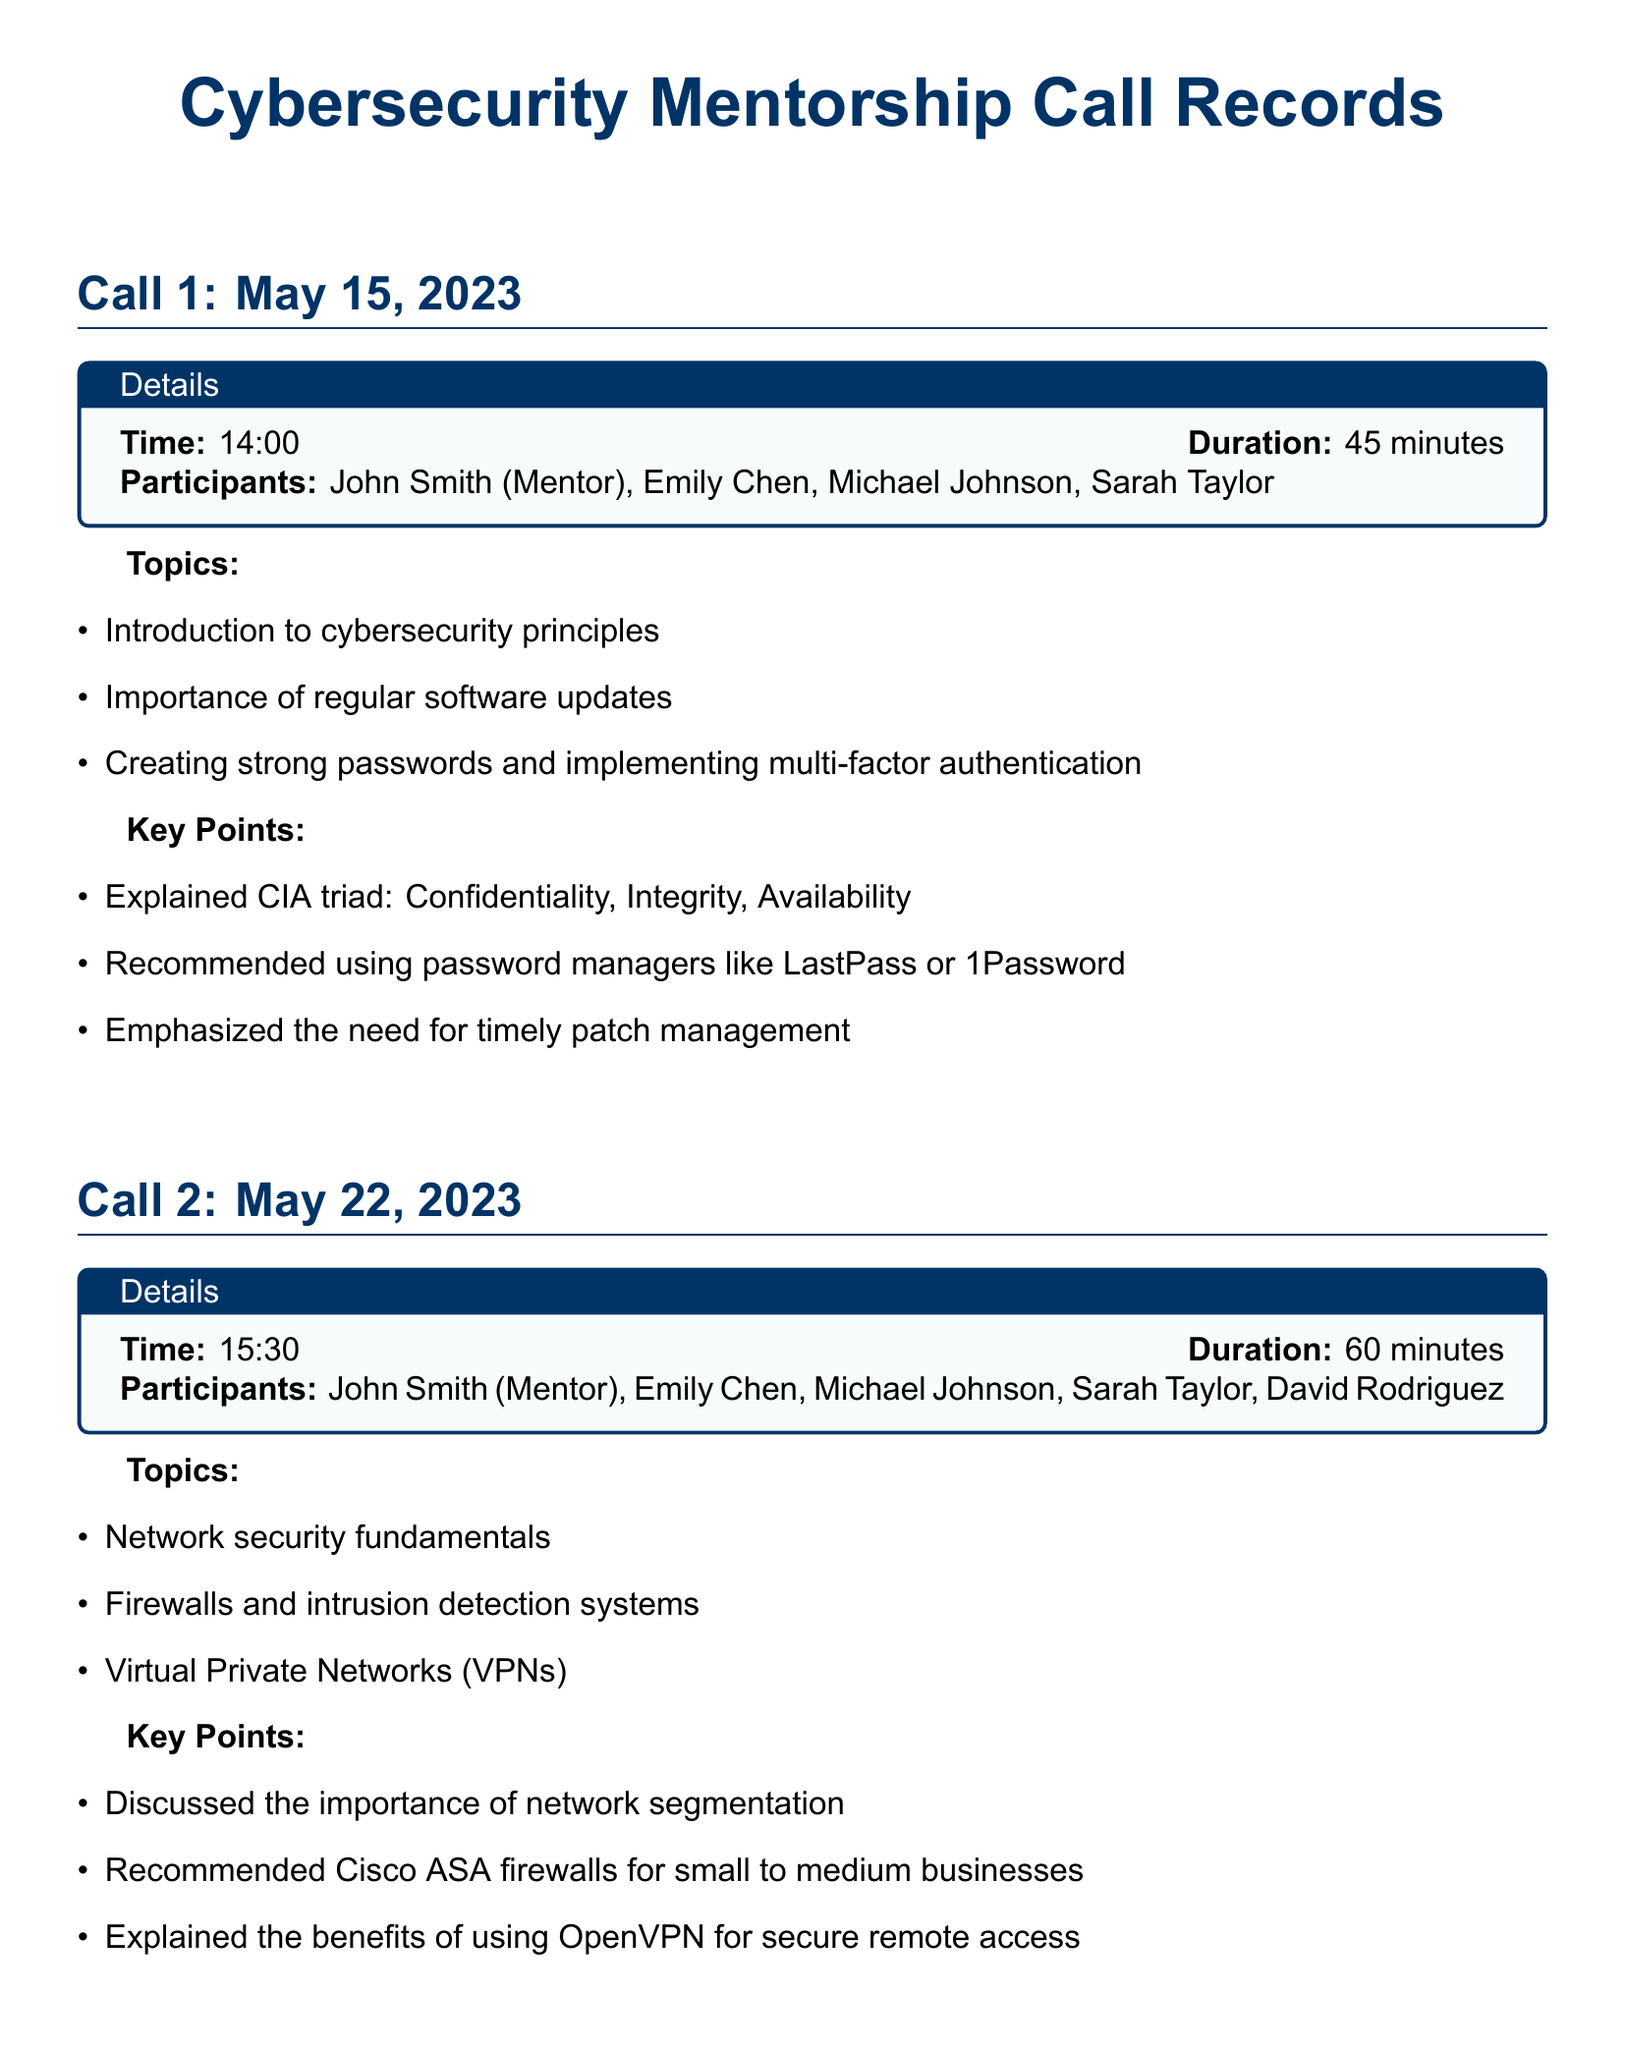What is the date of Call 1? The date of Call 1 is explicitly stated in the document under the section title for Call 1.
Answer: May 15, 2023 Who is the mentor for the conference calls? The mentor is mentioned at the beginning of each call details section, identifying John Smith as the mentor.
Answer: John Smith What was the duration of Call 2? The duration of Call 2 is provided in the details box for that specific call.
Answer: 60 minutes What is one of the topics discussed in Call 3? This information can be found in the list of topics for Call 3, highlighting specific areas addressed during the call.
Answer: Phishing awareness and social engineering How many participants joined Call 2? The number of participants can be calculated from the names listed in the details box of Call 2.
Answer: 5 participants What cybersecurity tool was recommended for email security? The tool is explicitly mentioned in the key points of Call 3 that discusses email security best practices.
Answer: DMARC What is the main theme of Call 1? The main theme can be referenced from the list of topics discussed in Call 1.
Answer: Cybersecurity principles What kind of exercise was conducted during Call 3? This detail arises from the key points noted for Call 3, underscoring an interactive aspect of the session.
Answer: Live phishing email analysis exercise What color is used for the document title? The color of the document title is mentioned in the formatting details of the title section.
Answer: Deep blue 